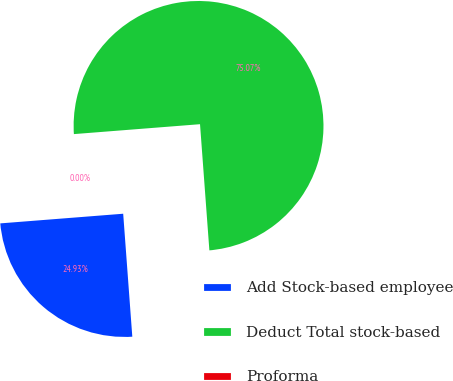Convert chart. <chart><loc_0><loc_0><loc_500><loc_500><pie_chart><fcel>Add Stock-based employee<fcel>Deduct Total stock-based<fcel>Proforma<nl><fcel>24.93%<fcel>75.07%<fcel>0.0%<nl></chart> 